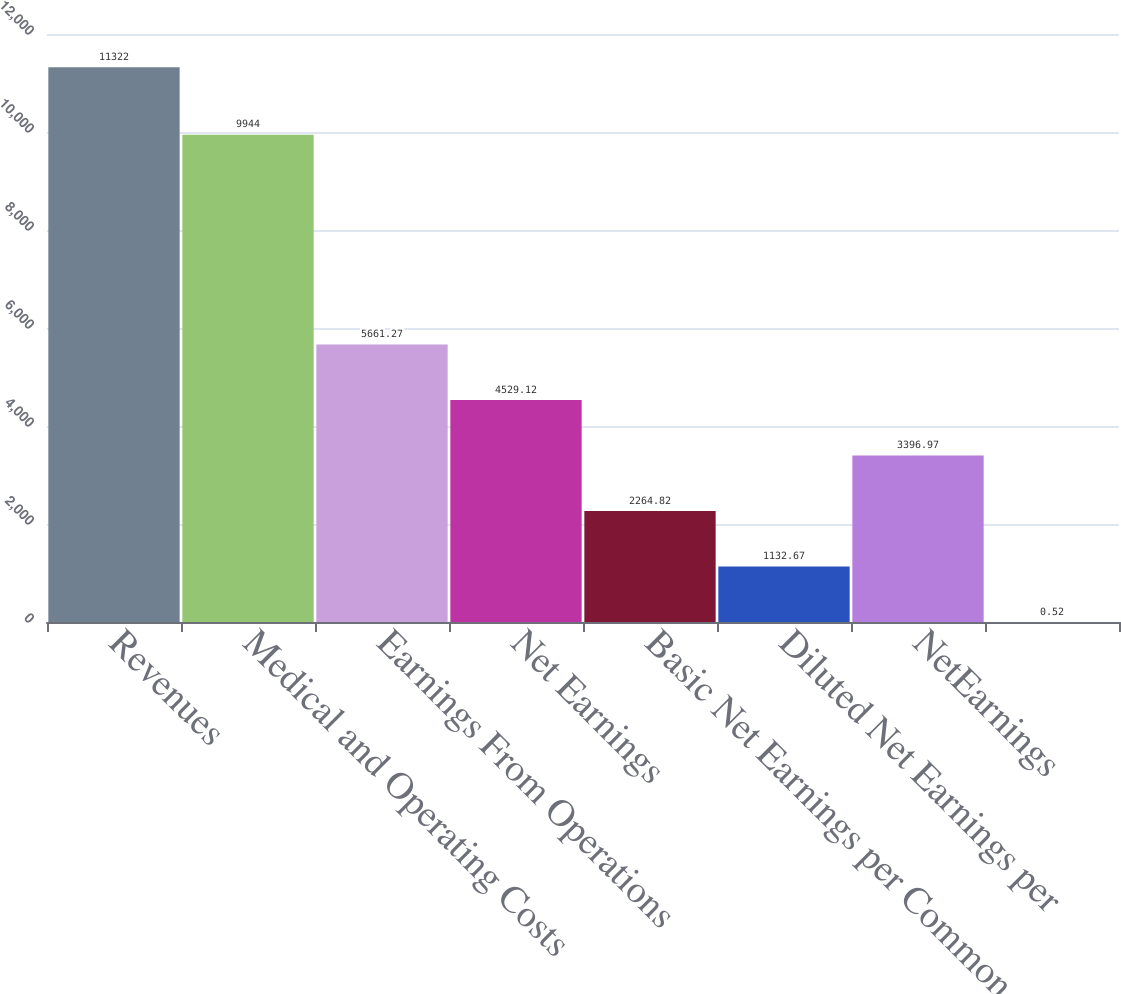<chart> <loc_0><loc_0><loc_500><loc_500><bar_chart><fcel>Revenues<fcel>Medical and Operating Costs<fcel>Earnings From Operations<fcel>Net Earnings<fcel>Basic Net Earnings per Common<fcel>Diluted Net Earnings per<fcel>NetEarnings<fcel>Unnamed: 7<nl><fcel>11322<fcel>9944<fcel>5661.27<fcel>4529.12<fcel>2264.82<fcel>1132.67<fcel>3396.97<fcel>0.52<nl></chart> 